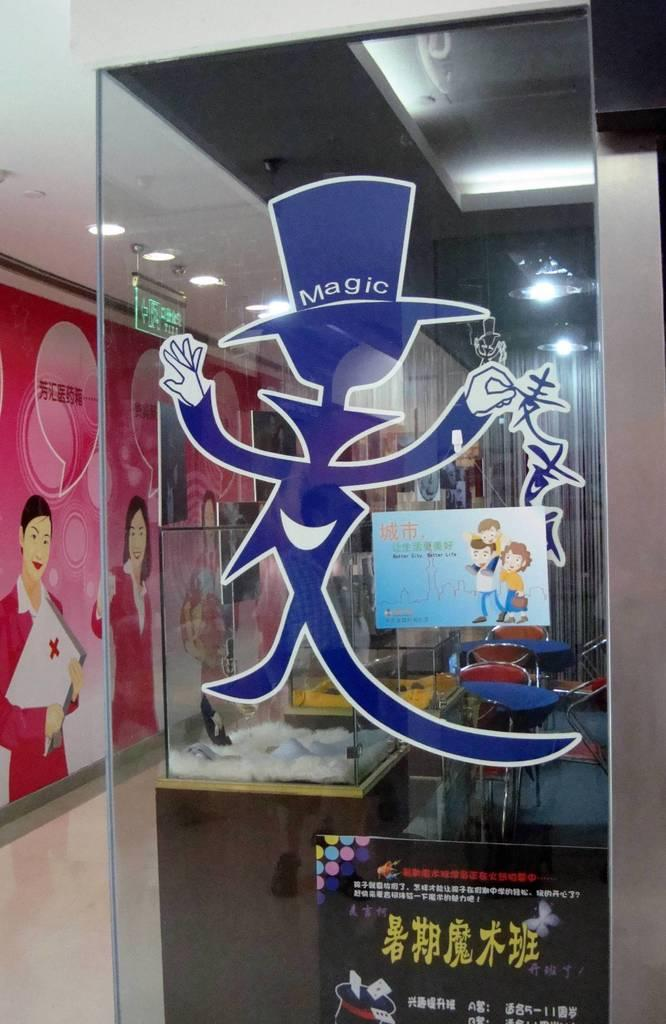<image>
Summarize the visual content of the image. A decal of a magician with a hat that says magic on a glass window. 